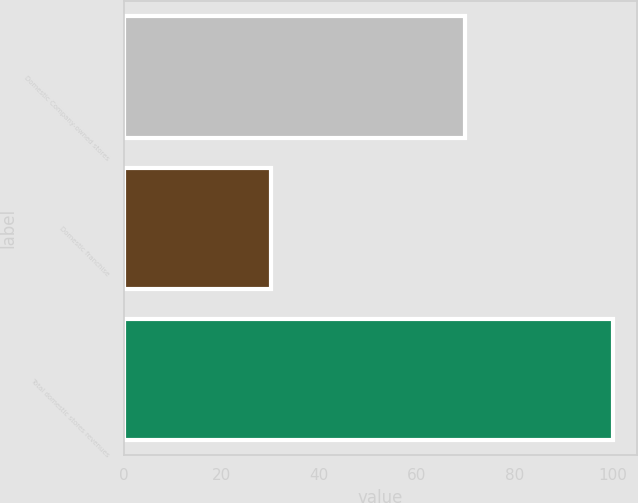Convert chart. <chart><loc_0><loc_0><loc_500><loc_500><bar_chart><fcel>Domestic Company-owned stores<fcel>Domestic franchise<fcel>Total domestic stores revenues<nl><fcel>69.9<fcel>30.1<fcel>100<nl></chart> 